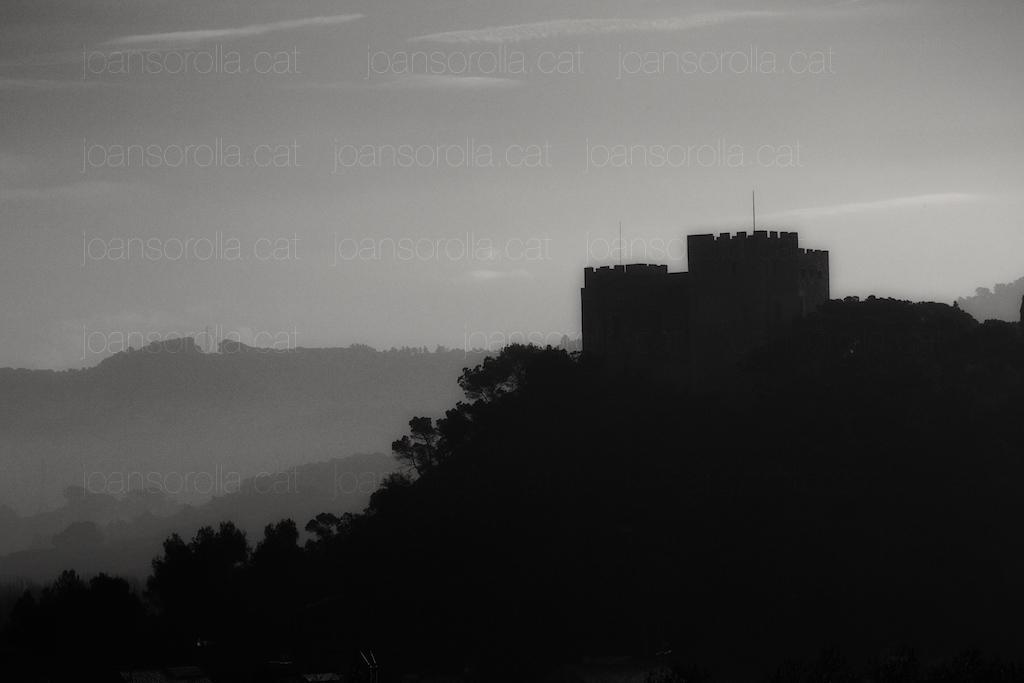Describe this image in one or two sentences. In this picture I can see the monument on the top of the mountain. Beside that I can see many trees. In the background I can see another mountains. At the top I can see the sky and clouds. In the center I can see the watermark. At the bottom I can see the darkness. 